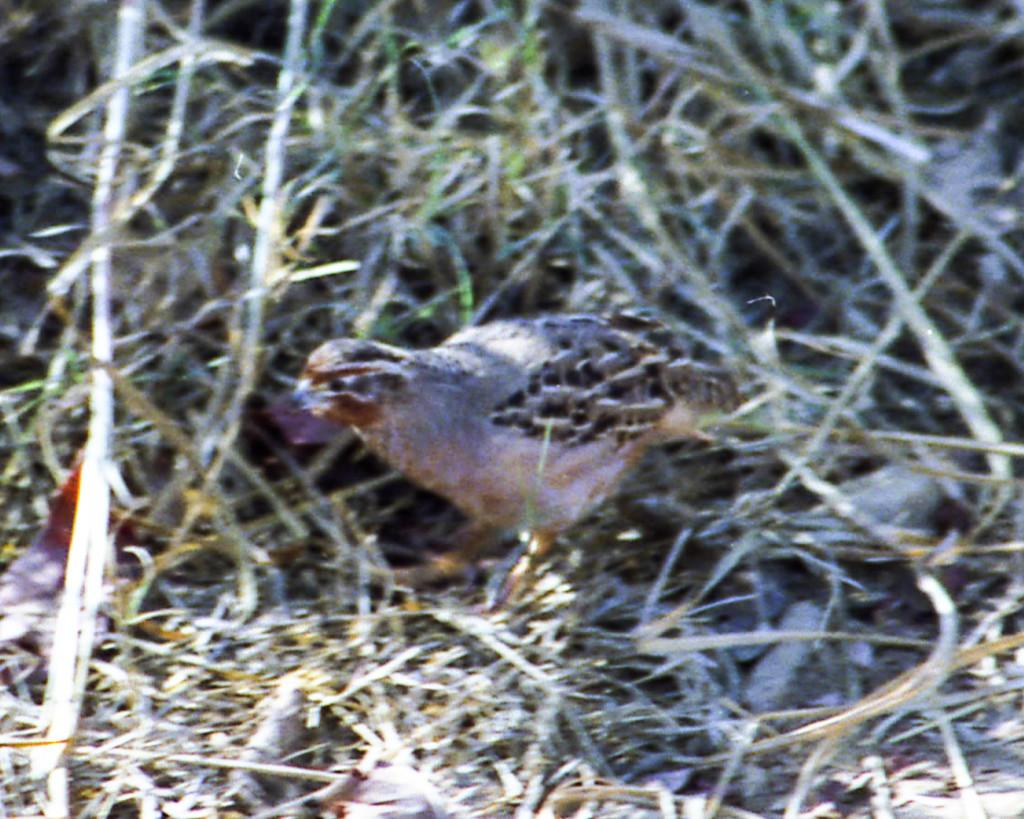What type of animal can be seen in the image? There is a bird in the image. Where is the bird located? The bird is on the grass. How many kittens are playing with a loaf of bread in the image? There are no kittens or loaf of bread present in the image; it features a bird on the grass. 